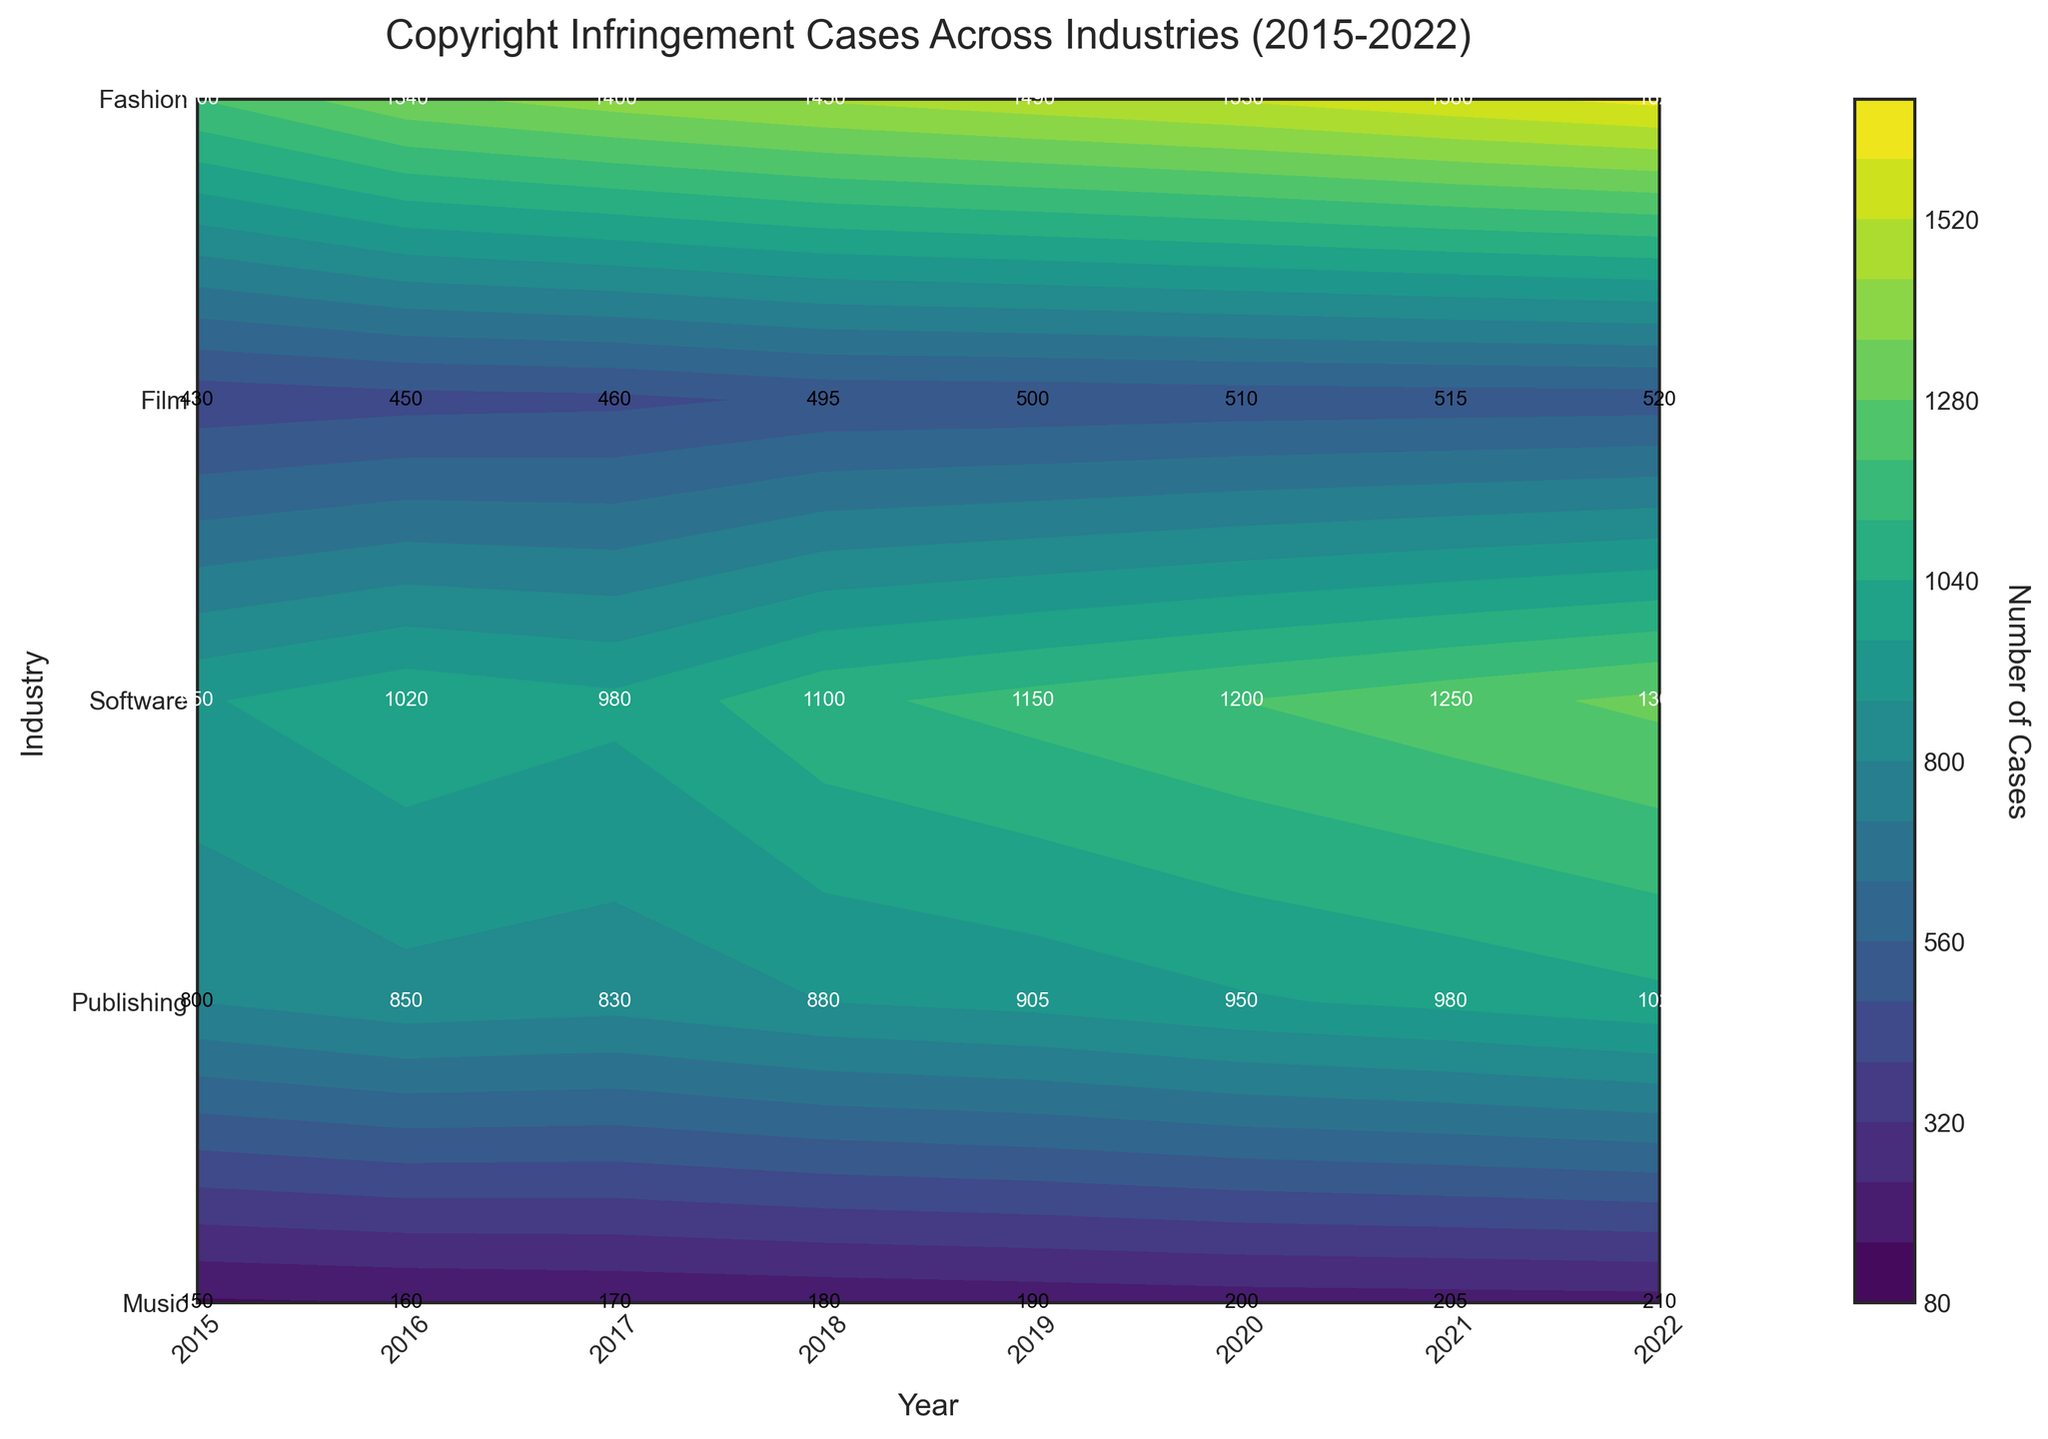What's the title of the figure? The title of the figure is displayed at the top center. It reads "Copyright Infringement Cases Across Industries (2015-2022)."
Answer: Copyright Infringement Cases Across Industries (2015-2022) Which industry had the highest number of copyright infringement cases in 2022? By looking at the vertical labels on the y-axis and the corresponding data for the year 2022, Software has the highest value.
Answer: Software How many Copyright Infringement Cases were there for the Film industry in 2018? Find the label for the Film industry on the y-axis and follow the data row to the year 2018. The number is written inside the contour plot. It is 880.
Answer: 880 What is the overall trend for the number of cases in the Music industry from 2015 to 2022? Check the data points along the line for the Music industry across the years 2015 to 2022. The numbers show a steady increase (950 to 1300).
Answer: Increasing Which years did the Publishing industry see no change in the number of cases? By checking the contour plot labels for the Publishing industry, the years 2019 and 2020 have the same value of 500.
Answer: 2019 and 2020 What is the average number of cases for the Fashion industry over the years? Add the number of cases from 2015 to 2022 for Fashion (150 + 160 + 170 + 180 + 190 + 200 + 205 + 210), which equals 1465. Divide by 8 (the number of years).
Answer: 183.125 Which industry saw the sharpest increase in cases between 2015 and 2022? Comparing each industry's cases in 2015 and 2022, Software increased from 1200 to 1625, the largest increase (425 cases).
Answer: Software How does the number of cases in 2016 in the Film industry compare to that in the Fashion industry? Check the respective values for the Film and Fashion industries in 2016 (850 and 160). The Film industry has more cases.
Answer: More in the Film industry What industry shows the most gradual increase in cases over the years? Checking each industry's data trends from 2015 to 2022, Publishing shows the most gradual increase.
Answer: Publishing 